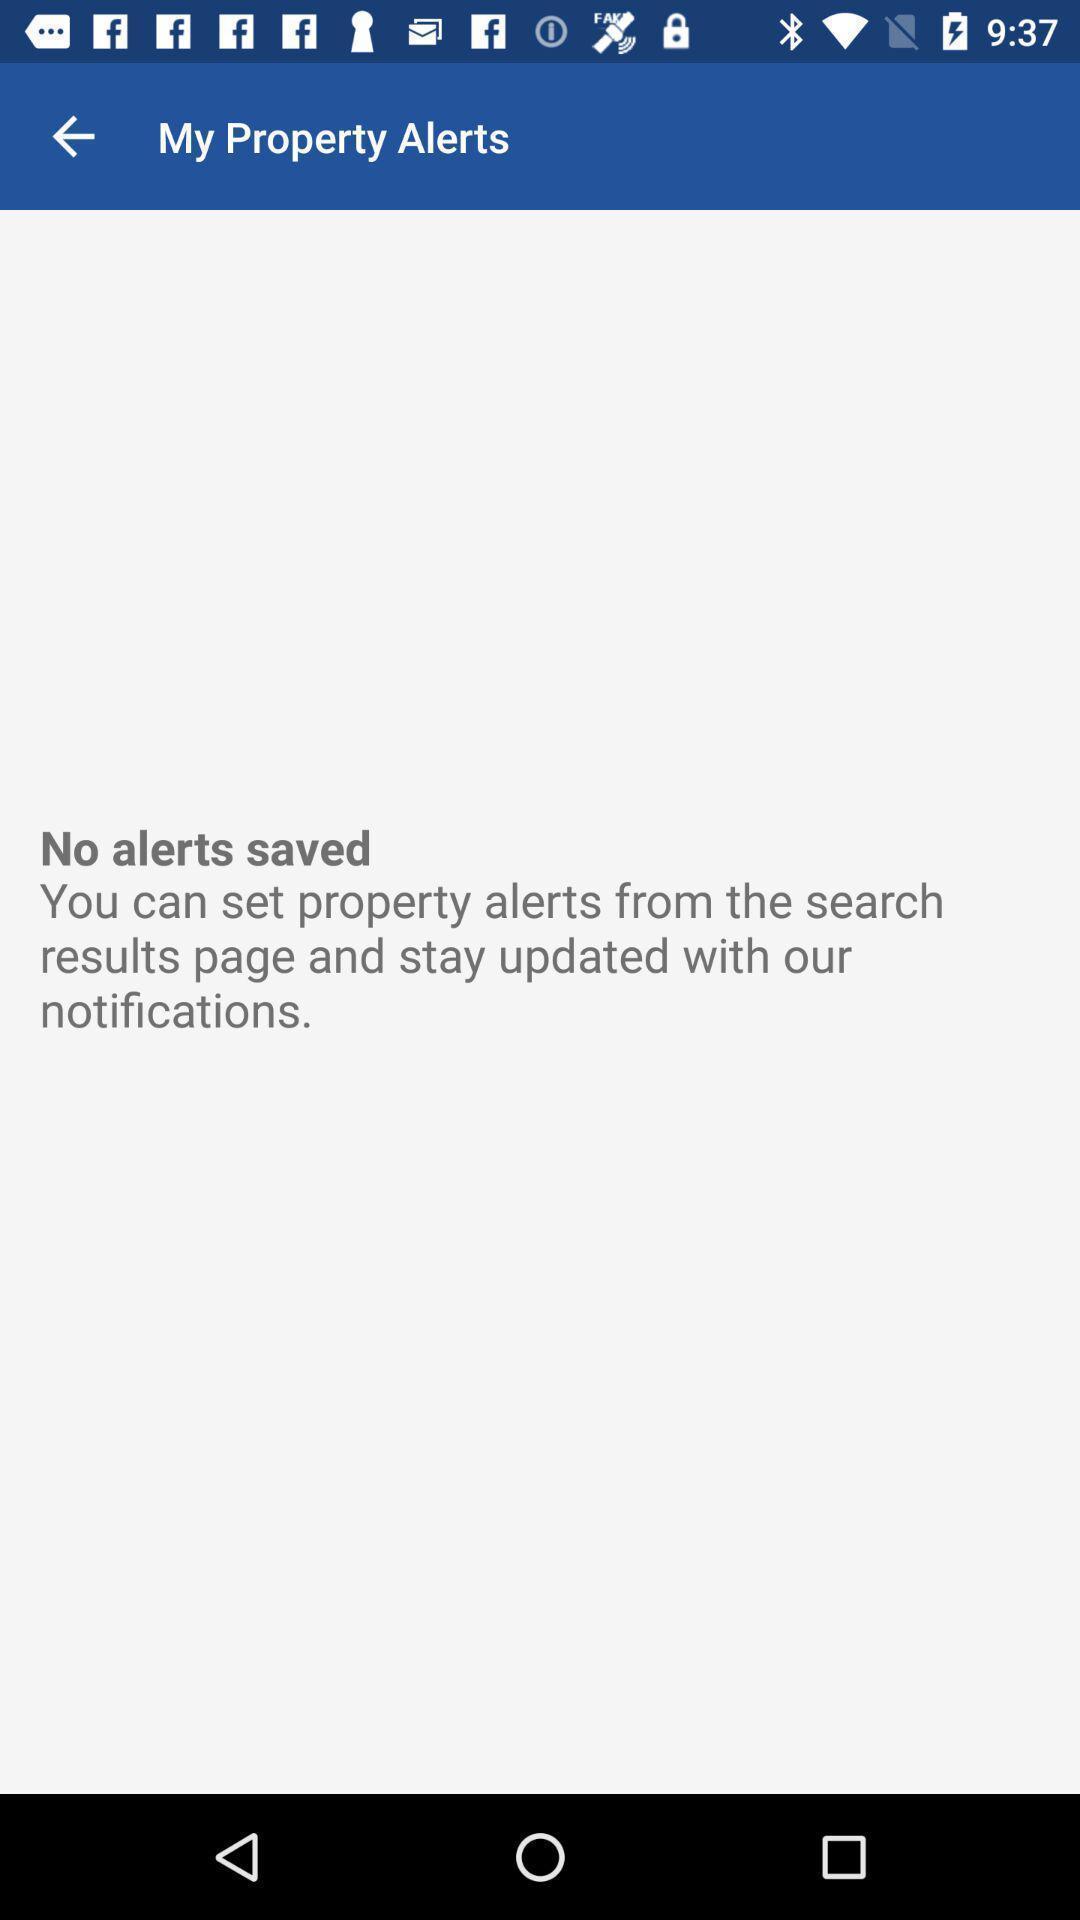Provide a description of this screenshot. Page showing no alerts saved in a property app. 